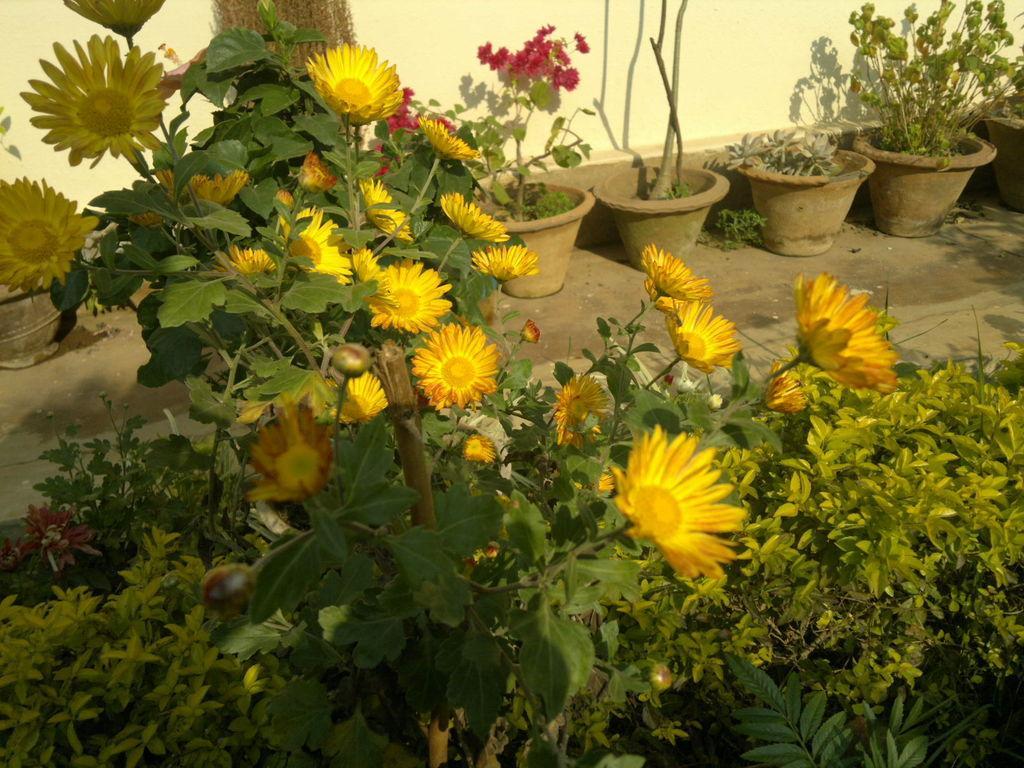How would you summarize this image in a sentence or two? In this picture we can see flowers, house plants on the ground, trees and in the background we can see wall. 